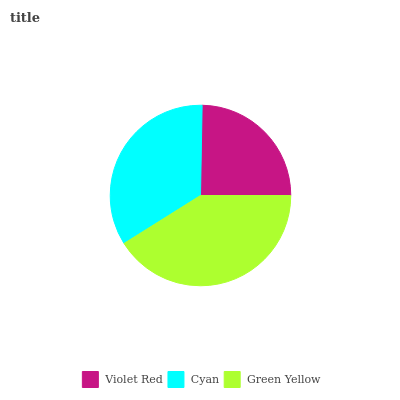Is Violet Red the minimum?
Answer yes or no. Yes. Is Green Yellow the maximum?
Answer yes or no. Yes. Is Cyan the minimum?
Answer yes or no. No. Is Cyan the maximum?
Answer yes or no. No. Is Cyan greater than Violet Red?
Answer yes or no. Yes. Is Violet Red less than Cyan?
Answer yes or no. Yes. Is Violet Red greater than Cyan?
Answer yes or no. No. Is Cyan less than Violet Red?
Answer yes or no. No. Is Cyan the high median?
Answer yes or no. Yes. Is Cyan the low median?
Answer yes or no. Yes. Is Violet Red the high median?
Answer yes or no. No. Is Green Yellow the low median?
Answer yes or no. No. 